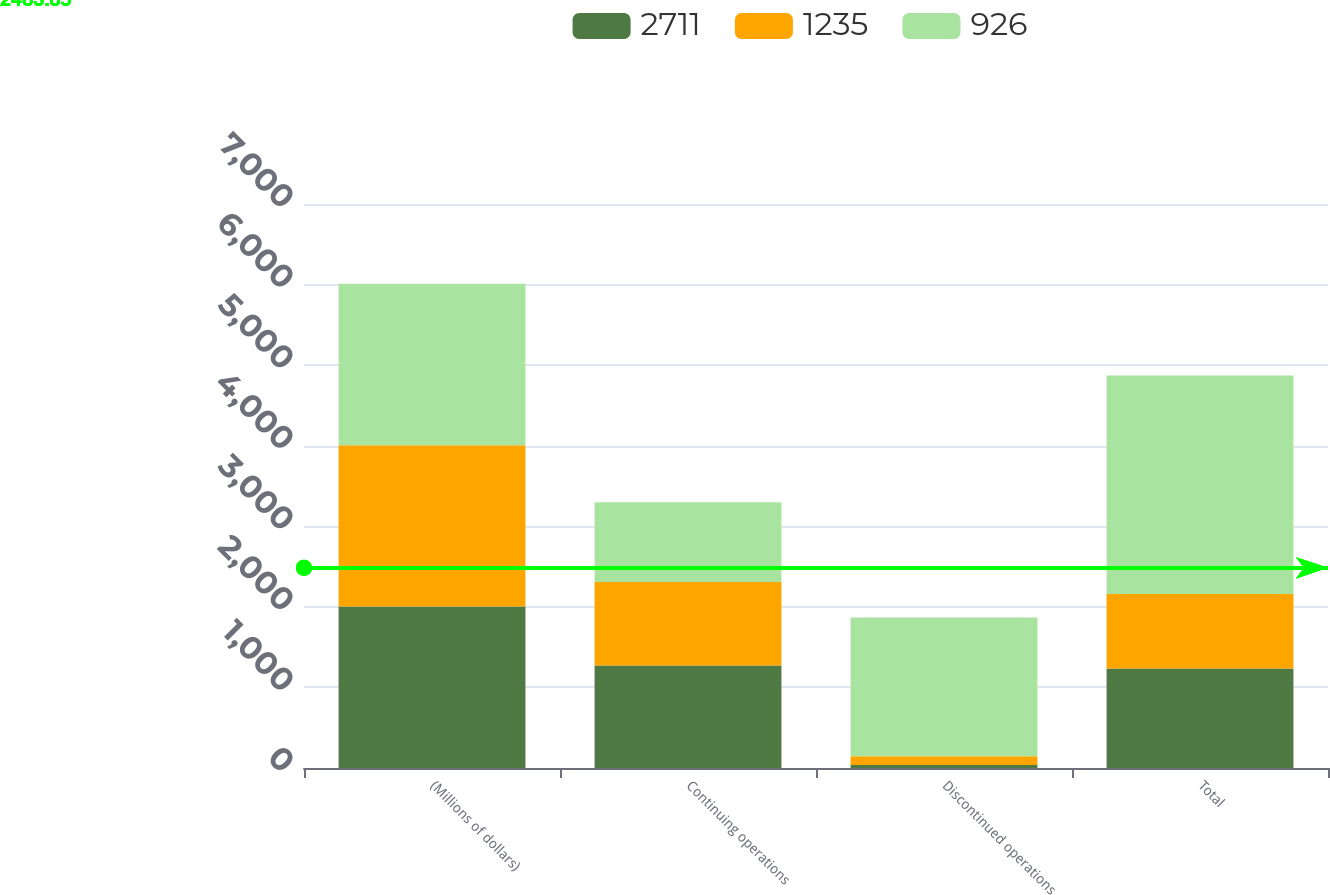Convert chart to OTSL. <chart><loc_0><loc_0><loc_500><loc_500><stacked_bar_chart><ecel><fcel>(Millions of dollars)<fcel>Continuing operations<fcel>Discontinued operations<fcel>Total<nl><fcel>2711<fcel>2004<fcel>1272<fcel>37<fcel>1235<nl><fcel>1235<fcel>2003<fcel>1036<fcel>110<fcel>926<nl><fcel>926<fcel>2002<fcel>990<fcel>1721<fcel>2711<nl></chart> 